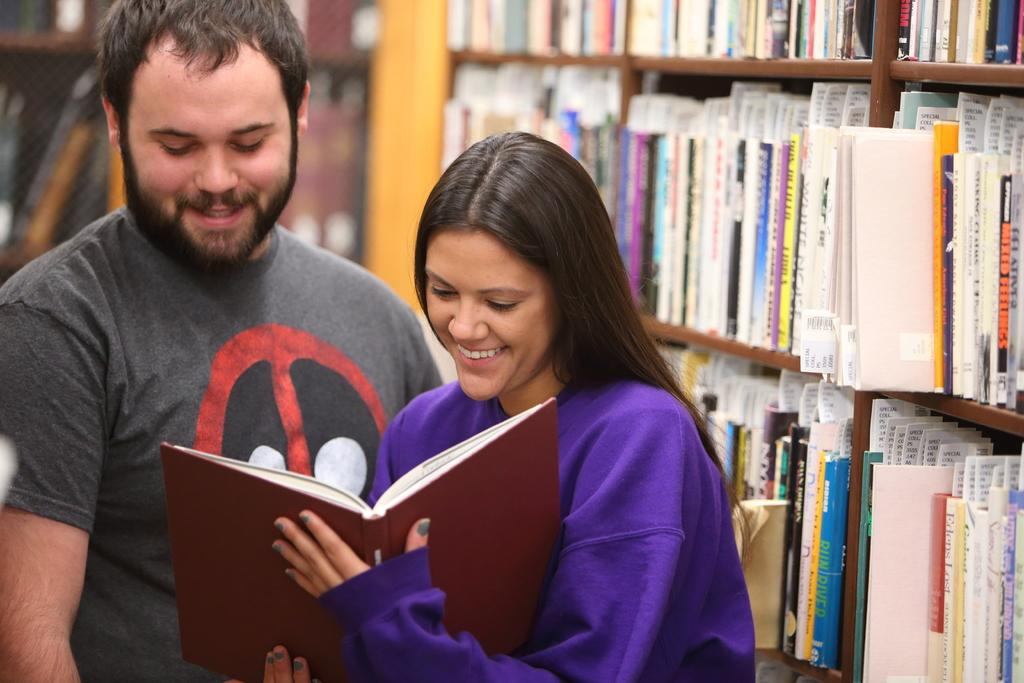How many people are in the image? There are two persons in the image. Where are the two persons located in the image? The two persons are standing on the bottom left side of the image. What is the facial expression of the two persons? The two persons are smiling. What are the two persons holding in the image? The two persons are holding a book. What can be seen behind the two persons? There is a bookshelf behind the two persons. What type of boats can be seen sailing on the grass in the image? There are no boats or grass present in the image; it features two persons standing and smiling while holding a book. 